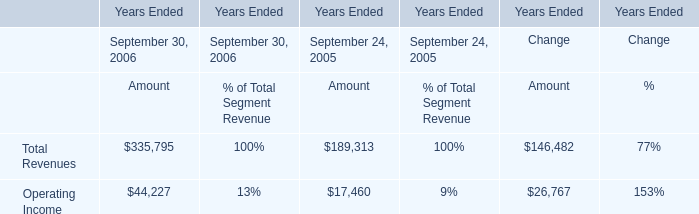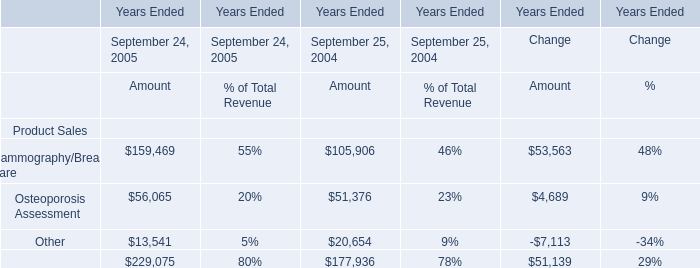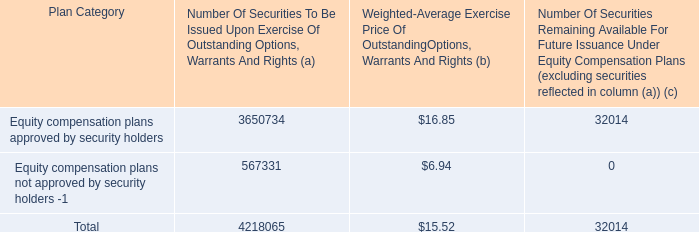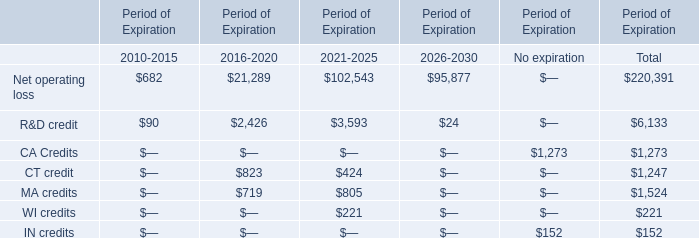In the section with largest amount of CT credit, what's the sum of Period of Expiration? 
Computations: (((21289 + 2426) + 823) + 719)
Answer: 25257.0. 